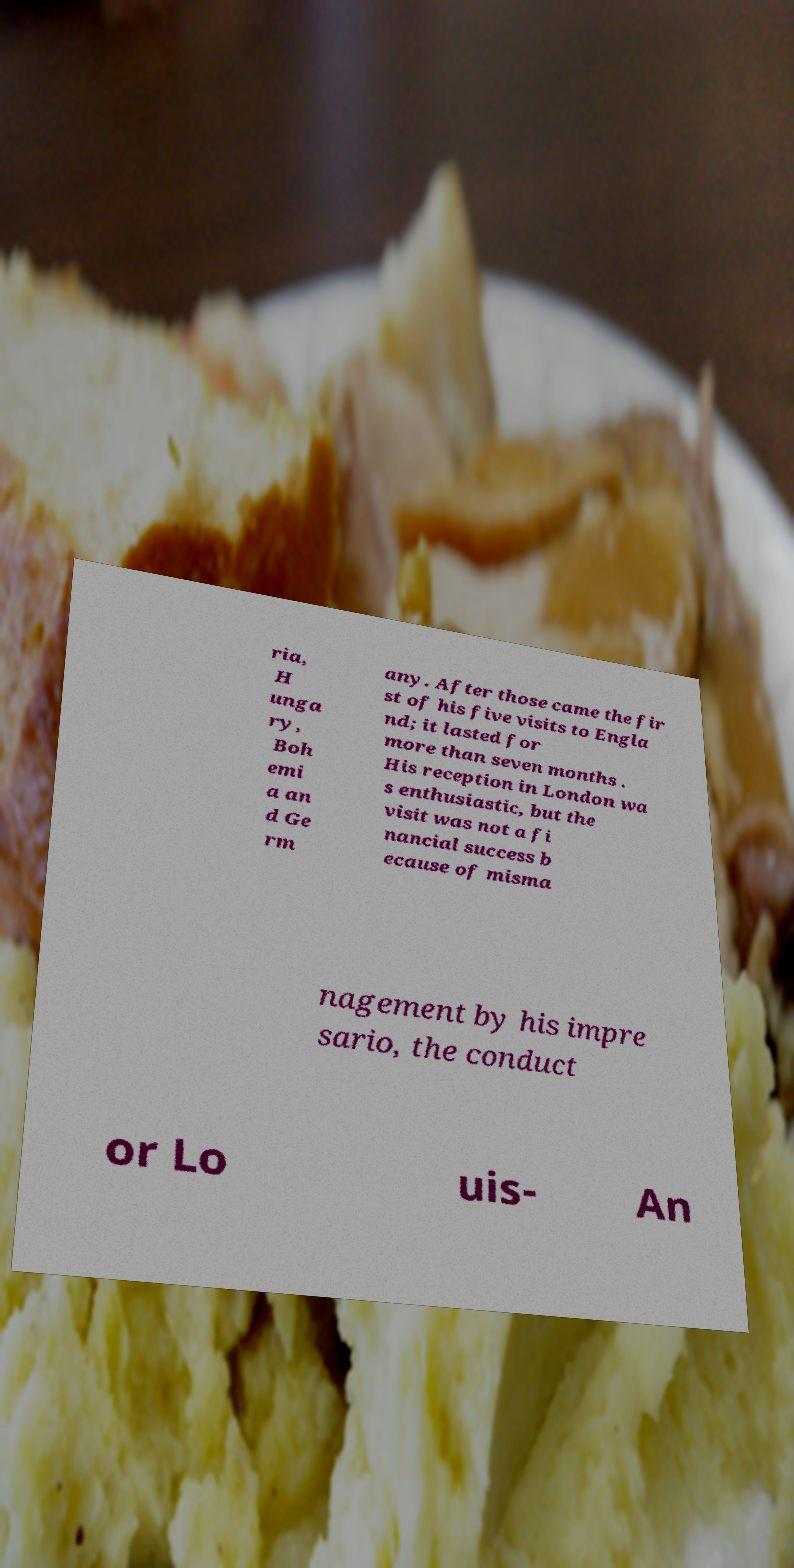Could you extract and type out the text from this image? ria, H unga ry, Boh emi a an d Ge rm any. After those came the fir st of his five visits to Engla nd; it lasted for more than seven months . His reception in London wa s enthusiastic, but the visit was not a fi nancial success b ecause of misma nagement by his impre sario, the conduct or Lo uis- An 